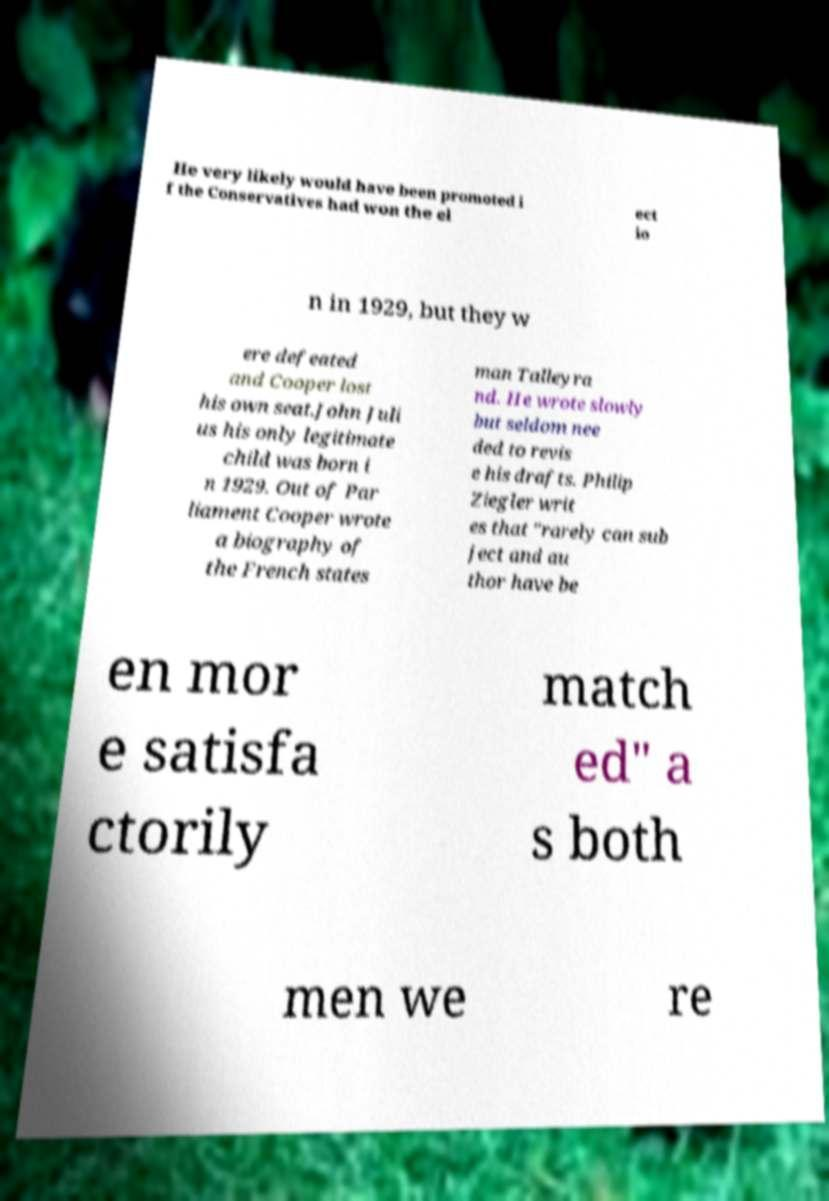Can you read and provide the text displayed in the image?This photo seems to have some interesting text. Can you extract and type it out for me? He very likely would have been promoted i f the Conservatives had won the el ect io n in 1929, but they w ere defeated and Cooper lost his own seat.John Juli us his only legitimate child was born i n 1929. Out of Par liament Cooper wrote a biography of the French states man Talleyra nd. He wrote slowly but seldom nee ded to revis e his drafts. Philip Ziegler writ es that "rarely can sub ject and au thor have be en mor e satisfa ctorily match ed" a s both men we re 